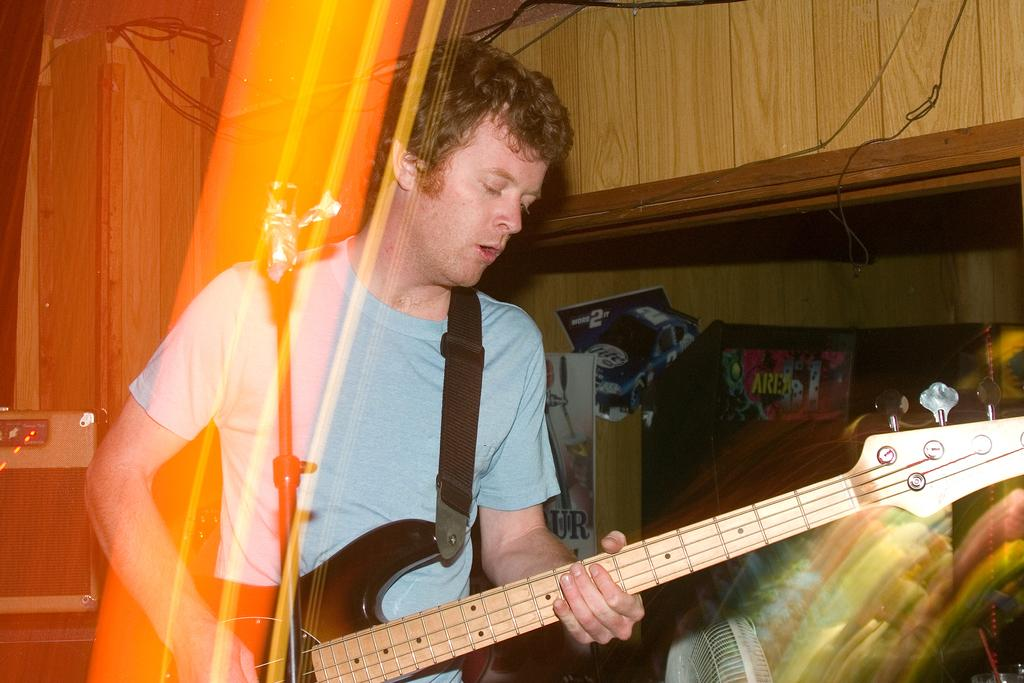What is the man in the image doing? The man in the image is playing a guitar and singing. What object is in front of the man that he might be using? There is a microphone with a holder in front of the man. What might be used to amplify the sound of the man's singing and guitar playing? There is a speaker visible in the image. What type of throat condition does the donkey have in the image? There is no donkey present in the image, so it is not possible to determine any throat conditions. What type of crown is the queen wearing in the image? There is no queen present in the image, so it is not possible to determine what type of crown she might be wearing. 